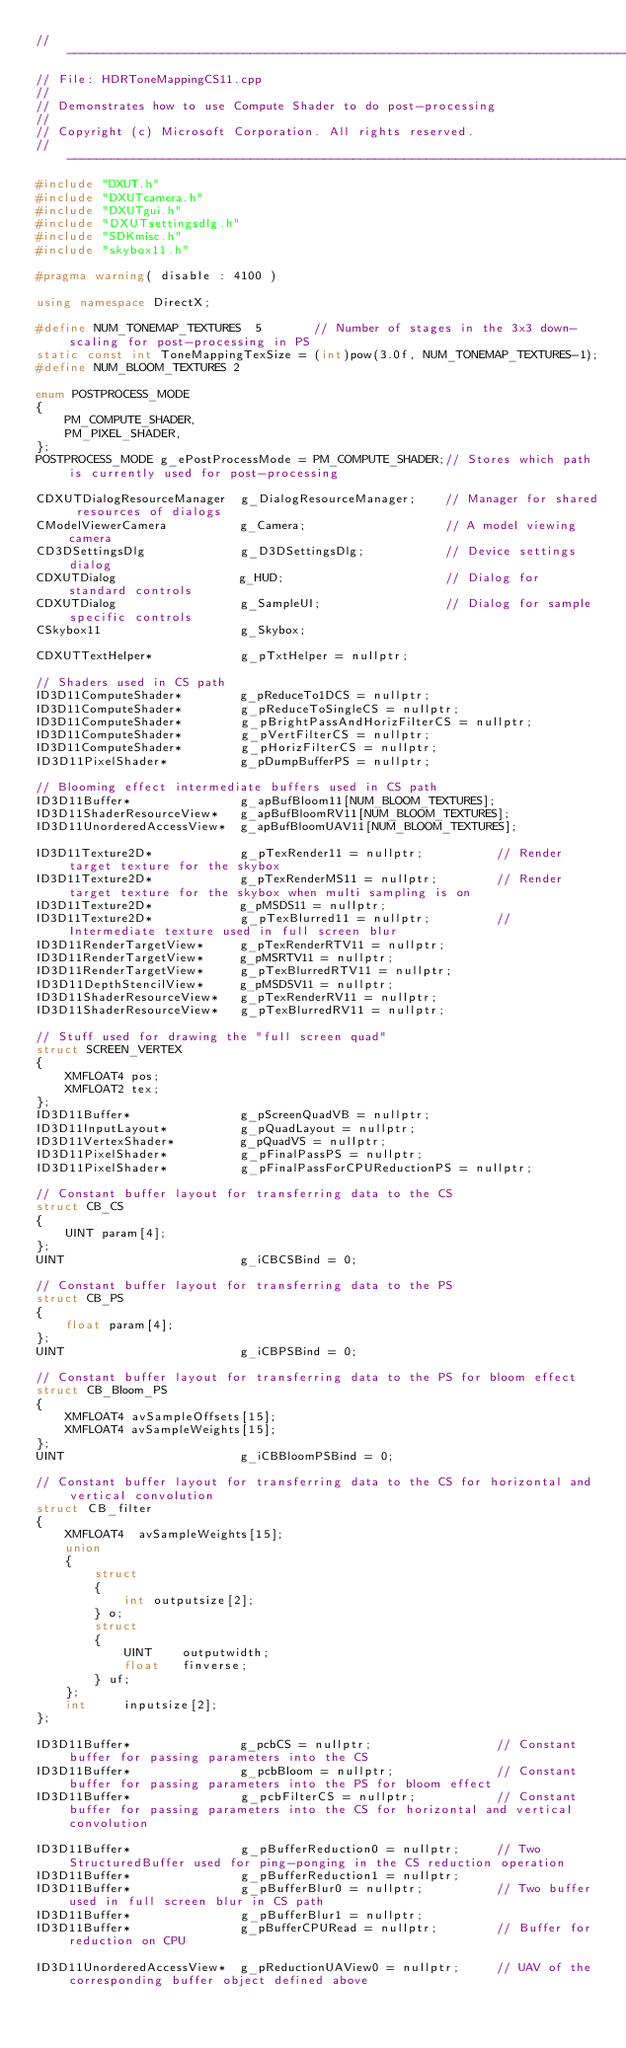<code> <loc_0><loc_0><loc_500><loc_500><_C++_>//--------------------------------------------------------------------------------------
// File: HDRToneMappingCS11.cpp
//
// Demonstrates how to use Compute Shader to do post-processing
//
// Copyright (c) Microsoft Corporation. All rights reserved.
//--------------------------------------------------------------------------------------
#include "DXUT.h"
#include "DXUTcamera.h"
#include "DXUTgui.h"
#include "DXUTsettingsdlg.h"
#include "SDKmisc.h"
#include "skybox11.h"

#pragma warning( disable : 4100 )

using namespace DirectX;

#define NUM_TONEMAP_TEXTURES  5       // Number of stages in the 3x3 down-scaling for post-processing in PS
static const int ToneMappingTexSize = (int)pow(3.0f, NUM_TONEMAP_TEXTURES-1);
#define NUM_BLOOM_TEXTURES 2

enum POSTPROCESS_MODE
{
    PM_COMPUTE_SHADER,
    PM_PIXEL_SHADER,
};
POSTPROCESS_MODE g_ePostProcessMode = PM_COMPUTE_SHADER;// Stores which path is currently used for post-processing

CDXUTDialogResourceManager  g_DialogResourceManager;    // Manager for shared resources of dialogs
CModelViewerCamera          g_Camera;                   // A model viewing camera
CD3DSettingsDlg             g_D3DSettingsDlg;           // Device settings dialog
CDXUTDialog                 g_HUD;                      // Dialog for standard controls
CDXUTDialog                 g_SampleUI;                 // Dialog for sample specific controls
CSkybox11                   g_Skybox;

CDXUTTextHelper*            g_pTxtHelper = nullptr;

// Shaders used in CS path
ID3D11ComputeShader*        g_pReduceTo1DCS = nullptr;
ID3D11ComputeShader*        g_pReduceToSingleCS = nullptr;
ID3D11ComputeShader*        g_pBrightPassAndHorizFilterCS = nullptr;
ID3D11ComputeShader*        g_pVertFilterCS = nullptr;
ID3D11ComputeShader*        g_pHorizFilterCS = nullptr;
ID3D11PixelShader*          g_pDumpBufferPS = nullptr;

// Blooming effect intermediate buffers used in CS path
ID3D11Buffer*               g_apBufBloom11[NUM_BLOOM_TEXTURES];         
ID3D11ShaderResourceView*   g_apBufBloomRV11[NUM_BLOOM_TEXTURES];
ID3D11UnorderedAccessView*  g_apBufBloomUAV11[NUM_BLOOM_TEXTURES];

ID3D11Texture2D*            g_pTexRender11 = nullptr;          // Render target texture for the skybox
ID3D11Texture2D*            g_pTexRenderMS11 = nullptr;        // Render target texture for the skybox when multi sampling is on
ID3D11Texture2D*            g_pMSDS11 = nullptr;
ID3D11Texture2D*            g_pTexBlurred11 = nullptr;         // Intermediate texture used in full screen blur
ID3D11RenderTargetView*     g_pTexRenderRTV11 = nullptr;       
ID3D11RenderTargetView*     g_pMSRTV11 = nullptr;
ID3D11RenderTargetView*     g_pTexBlurredRTV11 = nullptr;
ID3D11DepthStencilView*     g_pMSDSV11 = nullptr;
ID3D11ShaderResourceView*   g_pTexRenderRV11 = nullptr;        
ID3D11ShaderResourceView*   g_pTexBlurredRV11 = nullptr;

// Stuff used for drawing the "full screen quad"
struct SCREEN_VERTEX
{
    XMFLOAT4 pos;
    XMFLOAT2 tex;
};
ID3D11Buffer*               g_pScreenQuadVB = nullptr;
ID3D11InputLayout*          g_pQuadLayout = nullptr;
ID3D11VertexShader*         g_pQuadVS = nullptr;
ID3D11PixelShader*          g_pFinalPassPS = nullptr;
ID3D11PixelShader*          g_pFinalPassForCPUReductionPS = nullptr;

// Constant buffer layout for transferring data to the CS
struct CB_CS
{
    UINT param[4];
};
UINT                        g_iCBCSBind = 0;

// Constant buffer layout for transferring data to the PS
struct CB_PS
{
    float param[4];
};
UINT                        g_iCBPSBind = 0;

// Constant buffer layout for transferring data to the PS for bloom effect
struct CB_Bloom_PS
{
    XMFLOAT4 avSampleOffsets[15];
    XMFLOAT4 avSampleWeights[15];
};
UINT                        g_iCBBloomPSBind = 0;

// Constant buffer layout for transferring data to the CS for horizontal and vertical convolution
struct CB_filter
{
    XMFLOAT4  avSampleWeights[15];
    union
    {
        struct
        {
            int outputsize[2];
        } o;        
        struct 
        {
            UINT    outputwidth;
            float   finverse;
        } uf;
    };    
    int     inputsize[2];
};

ID3D11Buffer*               g_pcbCS = nullptr;                 // Constant buffer for passing parameters into the CS
ID3D11Buffer*               g_pcbBloom = nullptr;              // Constant buffer for passing parameters into the PS for bloom effect
ID3D11Buffer*               g_pcbFilterCS = nullptr;           // Constant buffer for passing parameters into the CS for horizontal and vertical convolution

ID3D11Buffer*               g_pBufferReduction0 = nullptr;     // Two StructuredBuffer used for ping-ponging in the CS reduction operation
ID3D11Buffer*               g_pBufferReduction1 = nullptr;
ID3D11Buffer*               g_pBufferBlur0 = nullptr;          // Two buffer used in full screen blur in CS path
ID3D11Buffer*               g_pBufferBlur1 = nullptr;
ID3D11Buffer*               g_pBufferCPURead = nullptr;        // Buffer for reduction on CPU

ID3D11UnorderedAccessView*  g_pReductionUAView0 = nullptr;     // UAV of the corresponding buffer object defined above</code> 